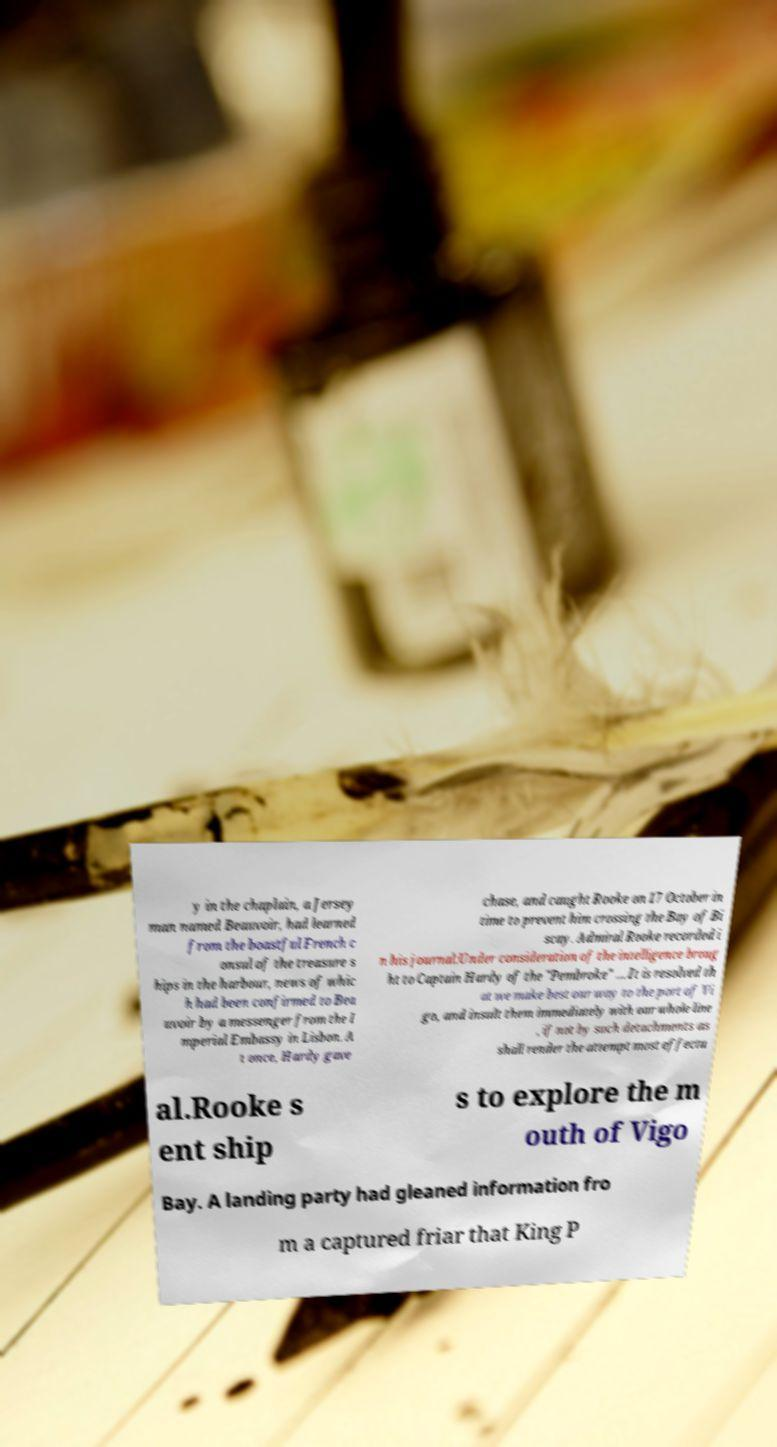I need the written content from this picture converted into text. Can you do that? y in the chaplain, a Jersey man named Beauvoir, had learned from the boastful French c onsul of the treasure s hips in the harbour, news of whic h had been confirmed to Bea uvoir by a messenger from the I mperial Embassy in Lisbon. A t once, Hardy gave chase, and caught Rooke on 17 October in time to prevent him crossing the Bay of Bi scay. Admiral Rooke recorded i n his journal:Under consideration of the intelligence broug ht to Captain Hardy of the "Pembroke" … It is resolved th at we make best our way to the port of Vi go, and insult them immediately with our whole line , if not by such detachments as shall render the attempt most effectu al.Rooke s ent ship s to explore the m outh of Vigo Bay. A landing party had gleaned information fro m a captured friar that King P 